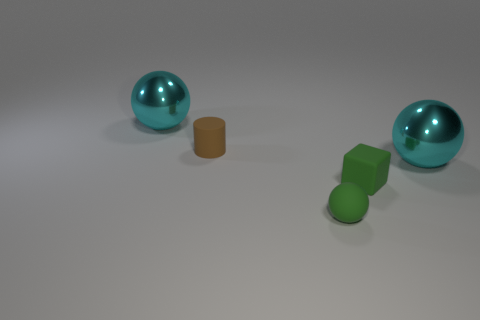Subtract all metallic balls. How many balls are left? 1 Add 2 big yellow things. How many objects exist? 7 Add 2 brown rubber cylinders. How many brown rubber cylinders exist? 3 Subtract 0 yellow cubes. How many objects are left? 5 Subtract all cylinders. How many objects are left? 4 Subtract all brown metallic blocks. Subtract all tiny cylinders. How many objects are left? 4 Add 5 tiny spheres. How many tiny spheres are left? 6 